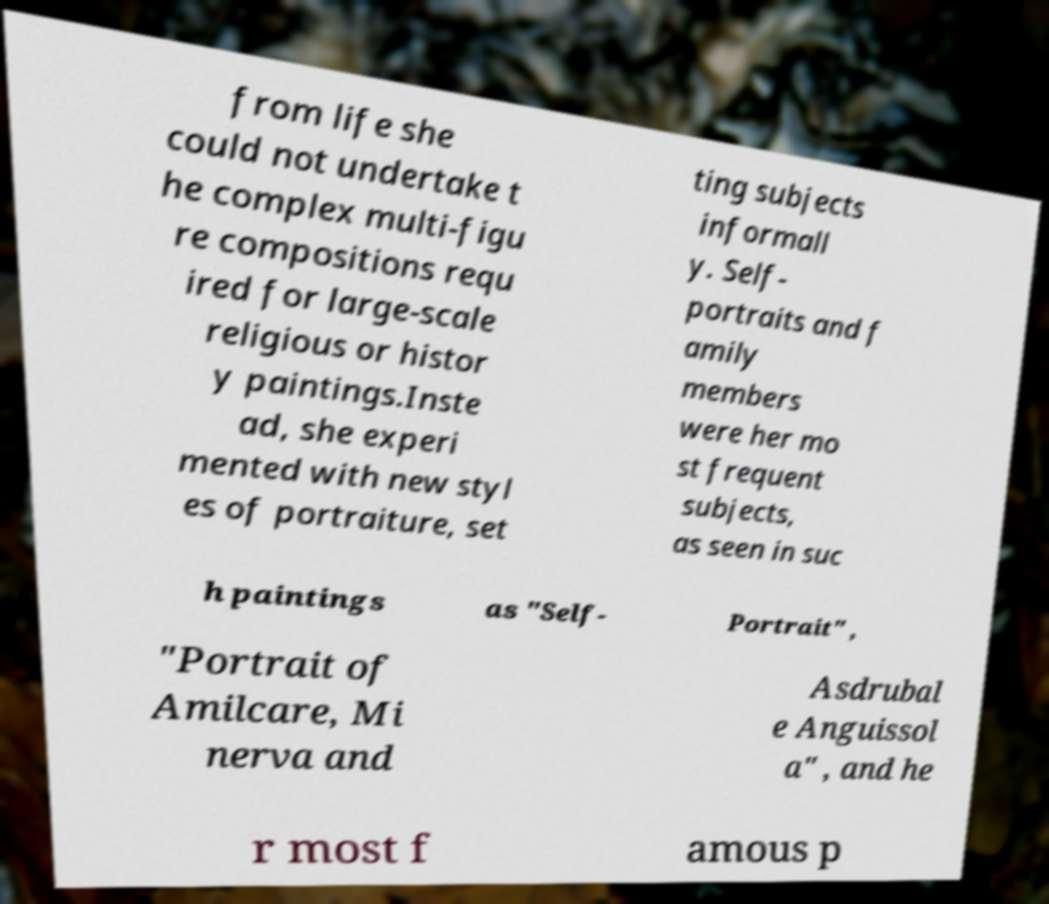Can you read and provide the text displayed in the image?This photo seems to have some interesting text. Can you extract and type it out for me? from life she could not undertake t he complex multi-figu re compositions requ ired for large-scale religious or histor y paintings.Inste ad, she experi mented with new styl es of portraiture, set ting subjects informall y. Self- portraits and f amily members were her mo st frequent subjects, as seen in suc h paintings as "Self- Portrait" , "Portrait of Amilcare, Mi nerva and Asdrubal e Anguissol a" , and he r most f amous p 